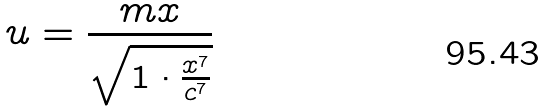<formula> <loc_0><loc_0><loc_500><loc_500>u = \frac { m x } { \sqrt { 1 \cdot \frac { x ^ { 7 } } { c ^ { 7 } } } }</formula> 